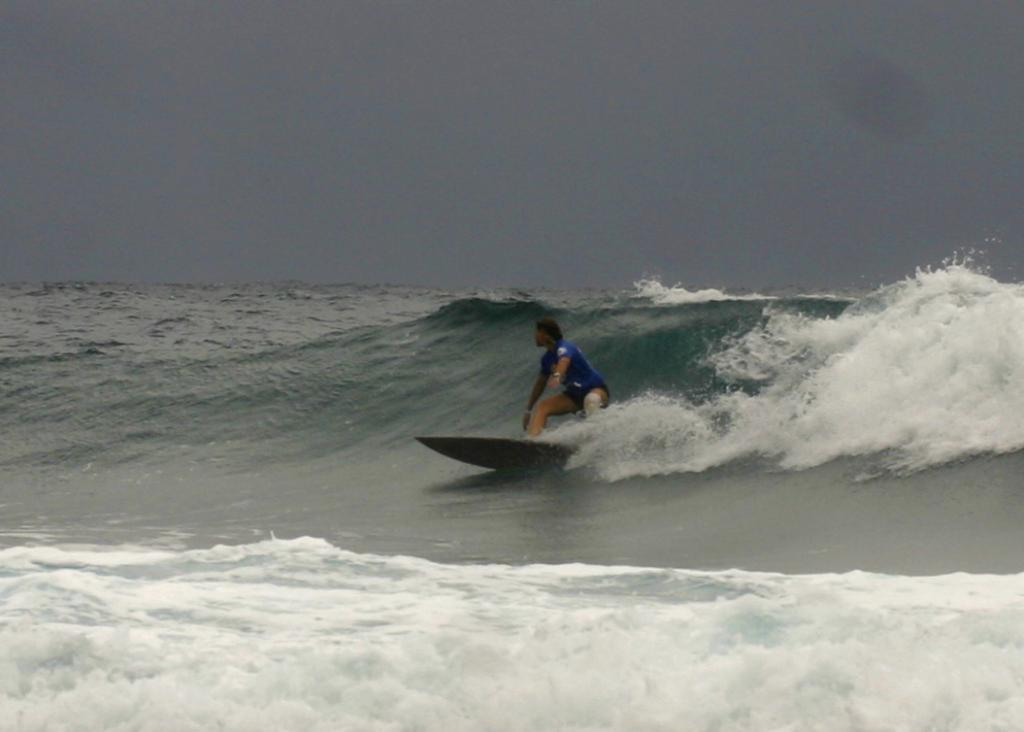Could you give a brief overview of what you see in this image? In this image I can see a man is surfing the sea, he wore blue color t-shirt, at the top it is the sky. 